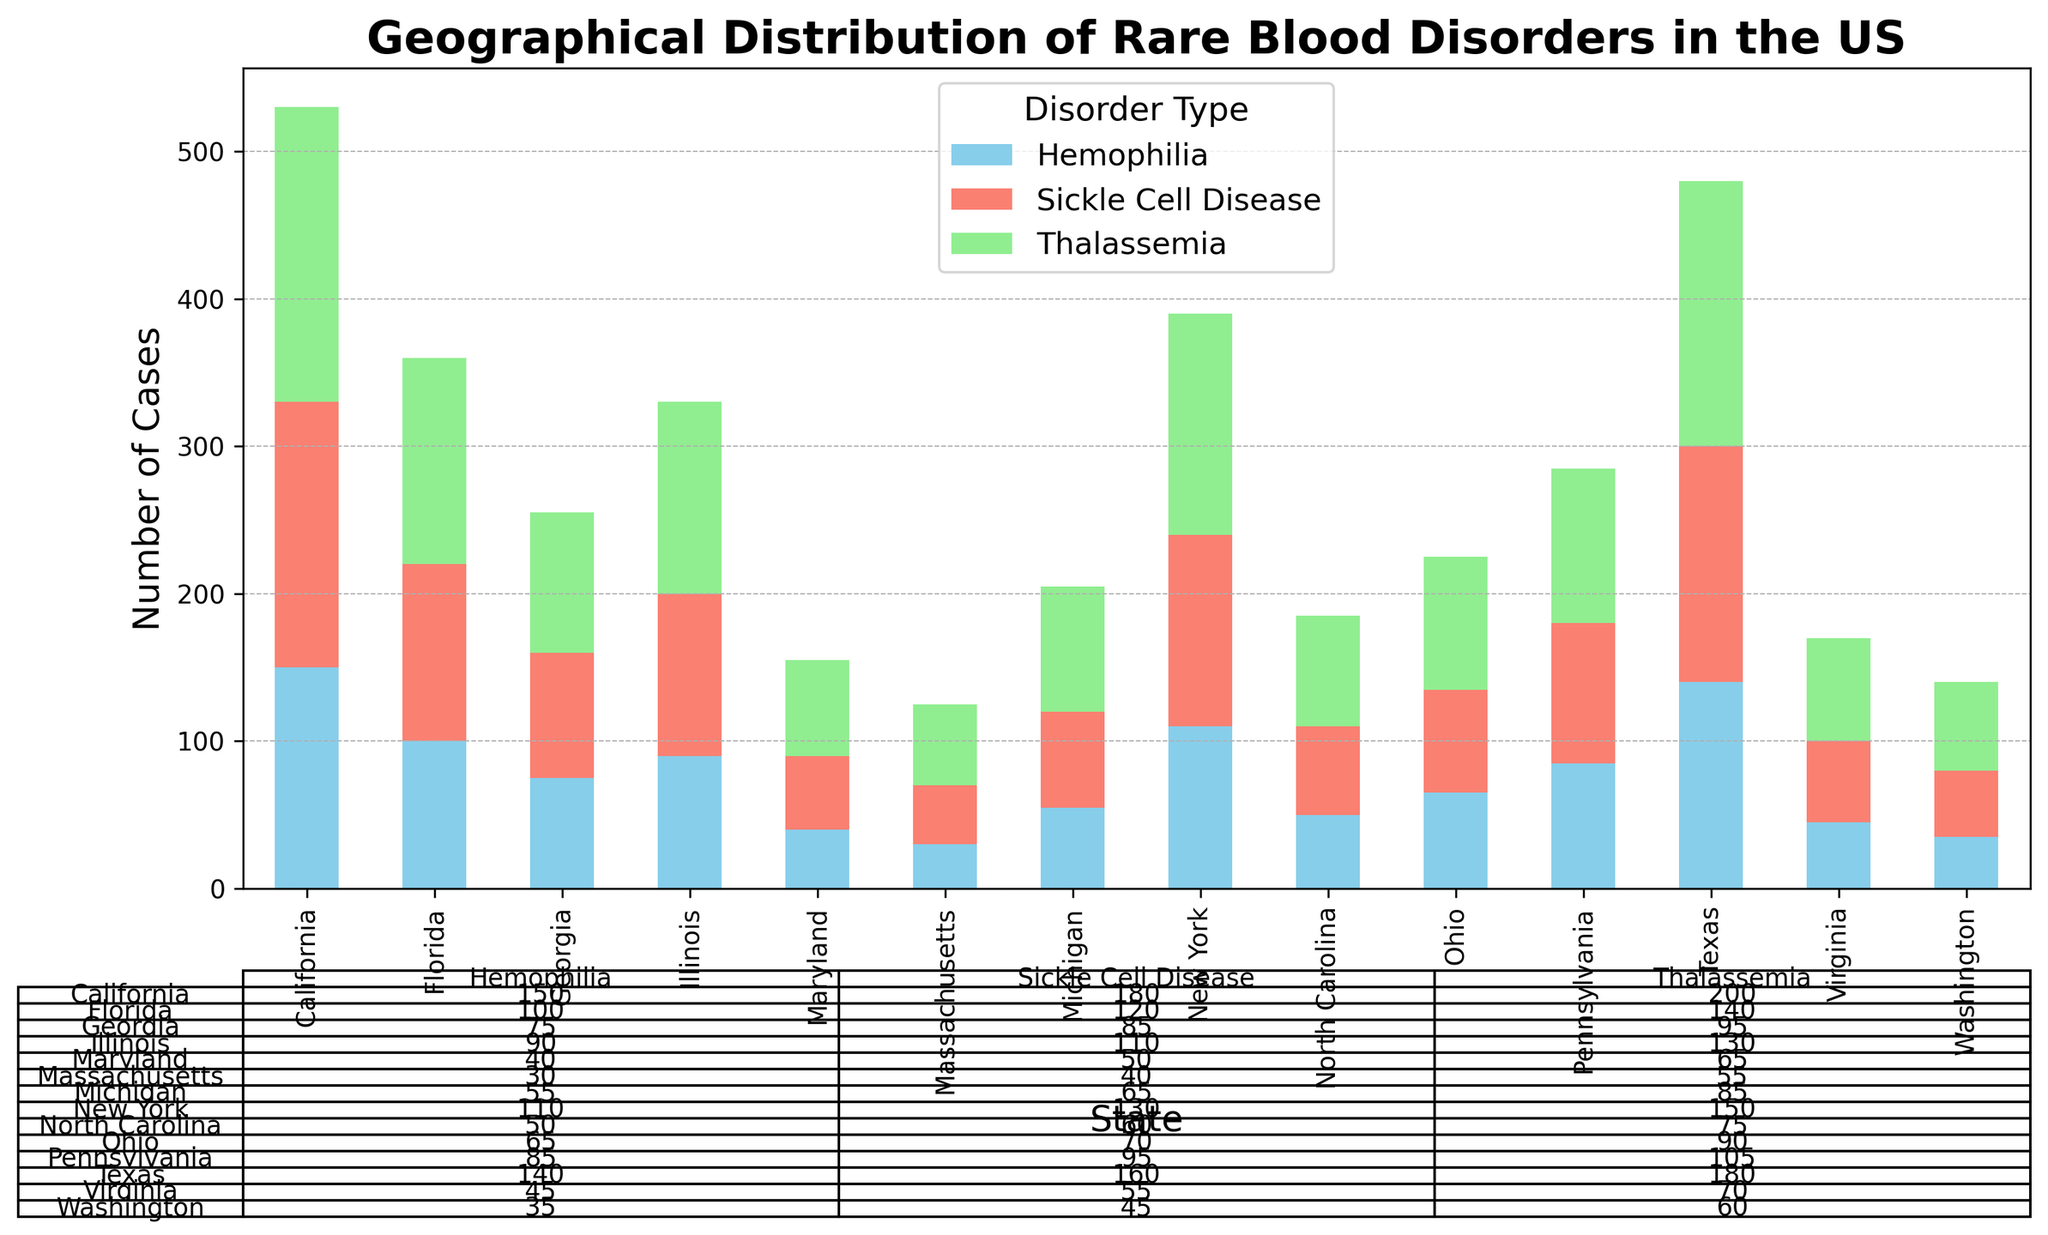Which state has the highest total number of rare blood disorder cases? Sum the number of cases for Thalassemia, Sickle Cell Disease, and Hemophilia for each state, and identify the state with the highest sum. California: 530, Texas: 480, New York: 390, Florida: 360, Illinois: 330, Pennsylvania: 285, Georgia: 255, Ohio: 225, Michigan: 205, North Carolina: 185, Virginia: 170, Maryland: 155, Washington: 140, Massachusetts: 125. California has the highest total number of cases.
Answer: California Which state has the lowest number of Hemophilia cases? Compare the number of Hemophilia cases across all states. The state with the smallest number is Maryaland.
Answer: Maryland How does the total number of cases in Florida compare to those in New York? Calculate the total number of cases for both states. Florida has a total of 360 cases and New York has 390 cases. New York has 30 more cases than Florida.
Answer: New York Which disorder type has the highest number of cases in Texas? Compare the number of cases for Thalassemia, Sickle Cell Disease, and Hemophilia in Texas. Thalassemia has the highest number of cases in Texas at 180.
Answer: Thalassemia What is the difference in the number of Sickle Cell Disease cases between California and Ohio? Subtract the number of Sickle Cell Disease cases in Ohio from the number in California. California has 180 cases and Ohio has 70. The difference is 110.
Answer: 110 In which state is Sickle Cell Disease the most common disorder type? For each state, compare the number of Sickle Cell Disease cases to those of Thalassemia and Hemophilia. Identify the state where Sickle Cell Disease has the highest number relative to the other disorders. California: 180, Texas: 160, New York: 130, Florida: 120, Illinois: 110, Pennsylvania: 95, Georgia: 85, Ohio: 70, Michigan: 65, North Carolina: 60, Virginia: 55, Maryland: 50, Washington: 45, Massachusetts: 40. California has the highest number of Sickle Cell Disease cases.
Answer: California What are the total number of cases of all disorder types combined in Pennsylvania? Add the number of cases for Thalassemia, Sickle Cell Disease, and Hemophilia in Pennsylvania. 105 + 95 + 85 = 285.
Answer: 285 How does the number of Thalassemia cases in Massachusetts compare to those in Washington? Compare the number of Thalassemia cases in both states. Massachusetts has 55 cases and Washington has 60 cases. Washington has 5 more cases than Massachusetts.
Answer: Washington Which states have more than 100 cases of each disorder type? Identify the states with more than 100 cases for Thalassemia, Sickle Cell Disease, and Hemophilia. Only California fits this criteria with 200 Thalassemia, 180 Sickle Cell Disease, and 150 Hemophilia cases.
Answer: California What's the average number of Hemophilia cases across all states? Sum the number of Hemophilia cases across all states and divide by the number of states. Total Hemophilia cases: 150 + 140 + 110 + 100 + 90 + 85 + 75 + 65 + 55 + 50 + 45 + 40 + 35 + 30 = 1165, divided by 14 states is approximately 83.21.
Answer: 83.21 